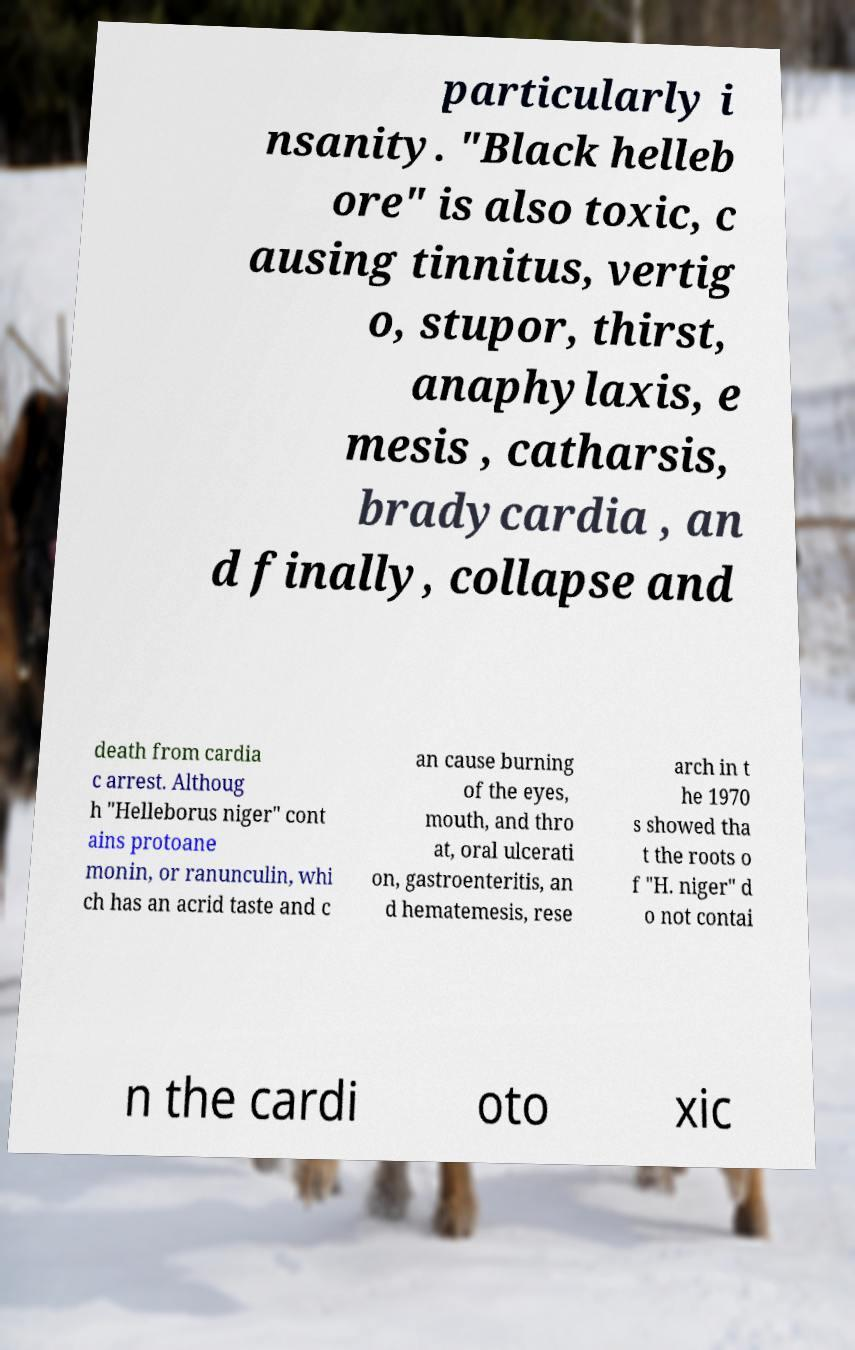Please read and relay the text visible in this image. What does it say? particularly i nsanity. "Black helleb ore" is also toxic, c ausing tinnitus, vertig o, stupor, thirst, anaphylaxis, e mesis , catharsis, bradycardia , an d finally, collapse and death from cardia c arrest. Althoug h "Helleborus niger" cont ains protoane monin, or ranunculin, whi ch has an acrid taste and c an cause burning of the eyes, mouth, and thro at, oral ulcerati on, gastroenteritis, an d hematemesis, rese arch in t he 1970 s showed tha t the roots o f "H. niger" d o not contai n the cardi oto xic 